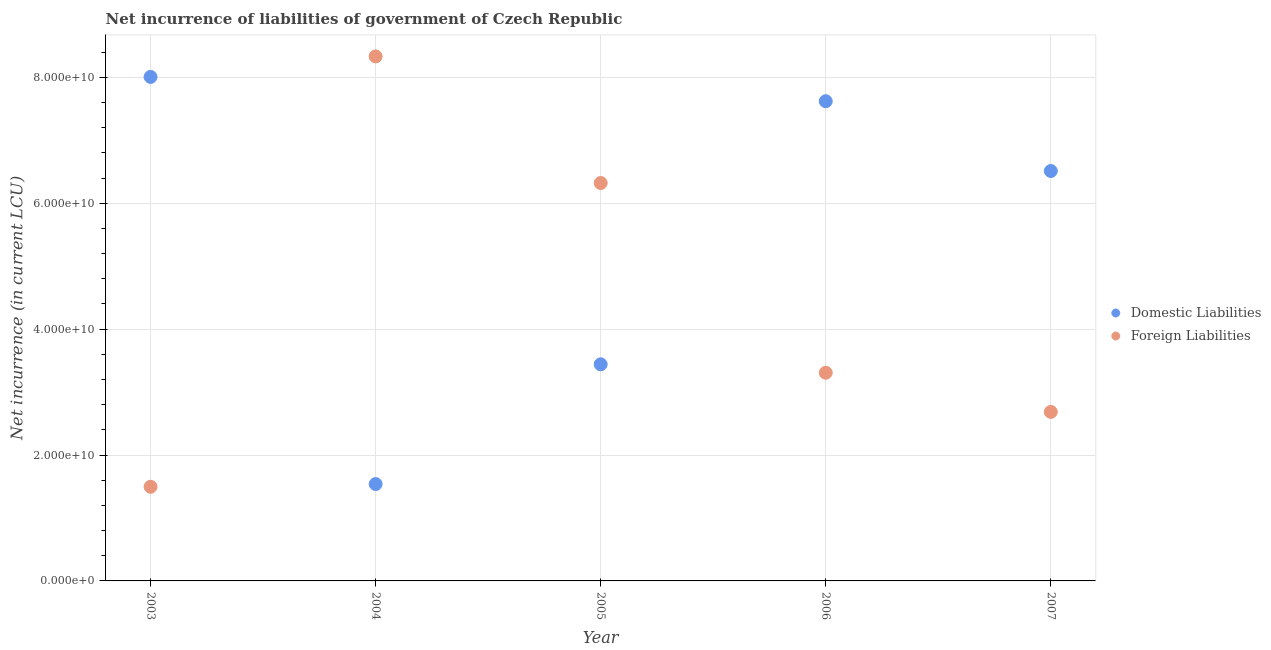How many different coloured dotlines are there?
Offer a very short reply. 2. What is the net incurrence of foreign liabilities in 2003?
Your answer should be compact. 1.50e+1. Across all years, what is the maximum net incurrence of domestic liabilities?
Your answer should be compact. 8.01e+1. Across all years, what is the minimum net incurrence of foreign liabilities?
Offer a terse response. 1.50e+1. In which year was the net incurrence of domestic liabilities maximum?
Give a very brief answer. 2003. What is the total net incurrence of domestic liabilities in the graph?
Ensure brevity in your answer.  2.71e+11. What is the difference between the net incurrence of domestic liabilities in 2003 and that in 2005?
Make the answer very short. 4.57e+1. What is the difference between the net incurrence of domestic liabilities in 2003 and the net incurrence of foreign liabilities in 2007?
Your answer should be compact. 5.32e+1. What is the average net incurrence of foreign liabilities per year?
Offer a terse response. 4.43e+1. In the year 2003, what is the difference between the net incurrence of domestic liabilities and net incurrence of foreign liabilities?
Offer a terse response. 6.51e+1. In how many years, is the net incurrence of foreign liabilities greater than 68000000000 LCU?
Offer a terse response. 1. What is the ratio of the net incurrence of foreign liabilities in 2003 to that in 2006?
Keep it short and to the point. 0.45. Is the net incurrence of foreign liabilities in 2004 less than that in 2007?
Provide a succinct answer. No. What is the difference between the highest and the second highest net incurrence of domestic liabilities?
Give a very brief answer. 3.86e+09. What is the difference between the highest and the lowest net incurrence of foreign liabilities?
Your answer should be compact. 6.84e+1. In how many years, is the net incurrence of foreign liabilities greater than the average net incurrence of foreign liabilities taken over all years?
Provide a succinct answer. 2. Does the net incurrence of foreign liabilities monotonically increase over the years?
Provide a short and direct response. No. Is the net incurrence of domestic liabilities strictly greater than the net incurrence of foreign liabilities over the years?
Make the answer very short. No. How many dotlines are there?
Make the answer very short. 2. How many years are there in the graph?
Your response must be concise. 5. Are the values on the major ticks of Y-axis written in scientific E-notation?
Ensure brevity in your answer.  Yes. How are the legend labels stacked?
Your answer should be very brief. Vertical. What is the title of the graph?
Ensure brevity in your answer.  Net incurrence of liabilities of government of Czech Republic. Does "Nonresident" appear as one of the legend labels in the graph?
Give a very brief answer. No. What is the label or title of the X-axis?
Your answer should be very brief. Year. What is the label or title of the Y-axis?
Provide a succinct answer. Net incurrence (in current LCU). What is the Net incurrence (in current LCU) of Domestic Liabilities in 2003?
Your response must be concise. 8.01e+1. What is the Net incurrence (in current LCU) of Foreign Liabilities in 2003?
Offer a terse response. 1.50e+1. What is the Net incurrence (in current LCU) of Domestic Liabilities in 2004?
Your answer should be very brief. 1.54e+1. What is the Net incurrence (in current LCU) in Foreign Liabilities in 2004?
Keep it short and to the point. 8.33e+1. What is the Net incurrence (in current LCU) in Domestic Liabilities in 2005?
Your answer should be compact. 3.44e+1. What is the Net incurrence (in current LCU) of Foreign Liabilities in 2005?
Your answer should be very brief. 6.32e+1. What is the Net incurrence (in current LCU) of Domestic Liabilities in 2006?
Give a very brief answer. 7.62e+1. What is the Net incurrence (in current LCU) in Foreign Liabilities in 2006?
Offer a terse response. 3.31e+1. What is the Net incurrence (in current LCU) of Domestic Liabilities in 2007?
Provide a succinct answer. 6.51e+1. What is the Net incurrence (in current LCU) of Foreign Liabilities in 2007?
Provide a short and direct response. 2.69e+1. Across all years, what is the maximum Net incurrence (in current LCU) of Domestic Liabilities?
Your answer should be very brief. 8.01e+1. Across all years, what is the maximum Net incurrence (in current LCU) of Foreign Liabilities?
Your response must be concise. 8.33e+1. Across all years, what is the minimum Net incurrence (in current LCU) in Domestic Liabilities?
Offer a terse response. 1.54e+1. Across all years, what is the minimum Net incurrence (in current LCU) of Foreign Liabilities?
Ensure brevity in your answer.  1.50e+1. What is the total Net incurrence (in current LCU) of Domestic Liabilities in the graph?
Offer a very short reply. 2.71e+11. What is the total Net incurrence (in current LCU) of Foreign Liabilities in the graph?
Provide a succinct answer. 2.21e+11. What is the difference between the Net incurrence (in current LCU) of Domestic Liabilities in 2003 and that in 2004?
Provide a short and direct response. 6.47e+1. What is the difference between the Net incurrence (in current LCU) in Foreign Liabilities in 2003 and that in 2004?
Your answer should be compact. -6.84e+1. What is the difference between the Net incurrence (in current LCU) in Domestic Liabilities in 2003 and that in 2005?
Give a very brief answer. 4.57e+1. What is the difference between the Net incurrence (in current LCU) of Foreign Liabilities in 2003 and that in 2005?
Your response must be concise. -4.83e+1. What is the difference between the Net incurrence (in current LCU) in Domestic Liabilities in 2003 and that in 2006?
Your answer should be compact. 3.86e+09. What is the difference between the Net incurrence (in current LCU) in Foreign Liabilities in 2003 and that in 2006?
Make the answer very short. -1.81e+1. What is the difference between the Net incurrence (in current LCU) of Domestic Liabilities in 2003 and that in 2007?
Your answer should be compact. 1.49e+1. What is the difference between the Net incurrence (in current LCU) of Foreign Liabilities in 2003 and that in 2007?
Keep it short and to the point. -1.19e+1. What is the difference between the Net incurrence (in current LCU) of Domestic Liabilities in 2004 and that in 2005?
Make the answer very short. -1.90e+1. What is the difference between the Net incurrence (in current LCU) in Foreign Liabilities in 2004 and that in 2005?
Make the answer very short. 2.01e+1. What is the difference between the Net incurrence (in current LCU) in Domestic Liabilities in 2004 and that in 2006?
Provide a short and direct response. -6.08e+1. What is the difference between the Net incurrence (in current LCU) of Foreign Liabilities in 2004 and that in 2006?
Offer a very short reply. 5.03e+1. What is the difference between the Net incurrence (in current LCU) of Domestic Liabilities in 2004 and that in 2007?
Make the answer very short. -4.97e+1. What is the difference between the Net incurrence (in current LCU) of Foreign Liabilities in 2004 and that in 2007?
Offer a terse response. 5.65e+1. What is the difference between the Net incurrence (in current LCU) of Domestic Liabilities in 2005 and that in 2006?
Give a very brief answer. -4.18e+1. What is the difference between the Net incurrence (in current LCU) in Foreign Liabilities in 2005 and that in 2006?
Give a very brief answer. 3.01e+1. What is the difference between the Net incurrence (in current LCU) in Domestic Liabilities in 2005 and that in 2007?
Ensure brevity in your answer.  -3.07e+1. What is the difference between the Net incurrence (in current LCU) of Foreign Liabilities in 2005 and that in 2007?
Your answer should be very brief. 3.64e+1. What is the difference between the Net incurrence (in current LCU) in Domestic Liabilities in 2006 and that in 2007?
Your answer should be compact. 1.11e+1. What is the difference between the Net incurrence (in current LCU) in Foreign Liabilities in 2006 and that in 2007?
Your response must be concise. 6.21e+09. What is the difference between the Net incurrence (in current LCU) in Domestic Liabilities in 2003 and the Net incurrence (in current LCU) in Foreign Liabilities in 2004?
Give a very brief answer. -3.26e+09. What is the difference between the Net incurrence (in current LCU) in Domestic Liabilities in 2003 and the Net incurrence (in current LCU) in Foreign Liabilities in 2005?
Offer a terse response. 1.69e+1. What is the difference between the Net incurrence (in current LCU) of Domestic Liabilities in 2003 and the Net incurrence (in current LCU) of Foreign Liabilities in 2006?
Give a very brief answer. 4.70e+1. What is the difference between the Net incurrence (in current LCU) in Domestic Liabilities in 2003 and the Net incurrence (in current LCU) in Foreign Liabilities in 2007?
Provide a short and direct response. 5.32e+1. What is the difference between the Net incurrence (in current LCU) of Domestic Liabilities in 2004 and the Net incurrence (in current LCU) of Foreign Liabilities in 2005?
Ensure brevity in your answer.  -4.78e+1. What is the difference between the Net incurrence (in current LCU) in Domestic Liabilities in 2004 and the Net incurrence (in current LCU) in Foreign Liabilities in 2006?
Ensure brevity in your answer.  -1.77e+1. What is the difference between the Net incurrence (in current LCU) in Domestic Liabilities in 2004 and the Net incurrence (in current LCU) in Foreign Liabilities in 2007?
Your response must be concise. -1.15e+1. What is the difference between the Net incurrence (in current LCU) of Domestic Liabilities in 2005 and the Net incurrence (in current LCU) of Foreign Liabilities in 2006?
Give a very brief answer. 1.34e+09. What is the difference between the Net incurrence (in current LCU) in Domestic Liabilities in 2005 and the Net incurrence (in current LCU) in Foreign Liabilities in 2007?
Make the answer very short. 7.56e+09. What is the difference between the Net incurrence (in current LCU) of Domestic Liabilities in 2006 and the Net incurrence (in current LCU) of Foreign Liabilities in 2007?
Provide a short and direct response. 4.93e+1. What is the average Net incurrence (in current LCU) in Domestic Liabilities per year?
Your response must be concise. 5.42e+1. What is the average Net incurrence (in current LCU) in Foreign Liabilities per year?
Your answer should be very brief. 4.43e+1. In the year 2003, what is the difference between the Net incurrence (in current LCU) of Domestic Liabilities and Net incurrence (in current LCU) of Foreign Liabilities?
Make the answer very short. 6.51e+1. In the year 2004, what is the difference between the Net incurrence (in current LCU) of Domestic Liabilities and Net incurrence (in current LCU) of Foreign Liabilities?
Offer a terse response. -6.79e+1. In the year 2005, what is the difference between the Net incurrence (in current LCU) of Domestic Liabilities and Net incurrence (in current LCU) of Foreign Liabilities?
Keep it short and to the point. -2.88e+1. In the year 2006, what is the difference between the Net incurrence (in current LCU) in Domestic Liabilities and Net incurrence (in current LCU) in Foreign Liabilities?
Provide a short and direct response. 4.31e+1. In the year 2007, what is the difference between the Net incurrence (in current LCU) in Domestic Liabilities and Net incurrence (in current LCU) in Foreign Liabilities?
Give a very brief answer. 3.83e+1. What is the ratio of the Net incurrence (in current LCU) of Domestic Liabilities in 2003 to that in 2004?
Provide a short and direct response. 5.2. What is the ratio of the Net incurrence (in current LCU) in Foreign Liabilities in 2003 to that in 2004?
Ensure brevity in your answer.  0.18. What is the ratio of the Net incurrence (in current LCU) of Domestic Liabilities in 2003 to that in 2005?
Your answer should be very brief. 2.33. What is the ratio of the Net incurrence (in current LCU) in Foreign Liabilities in 2003 to that in 2005?
Make the answer very short. 0.24. What is the ratio of the Net incurrence (in current LCU) in Domestic Liabilities in 2003 to that in 2006?
Provide a succinct answer. 1.05. What is the ratio of the Net incurrence (in current LCU) of Foreign Liabilities in 2003 to that in 2006?
Give a very brief answer. 0.45. What is the ratio of the Net incurrence (in current LCU) in Domestic Liabilities in 2003 to that in 2007?
Provide a succinct answer. 1.23. What is the ratio of the Net incurrence (in current LCU) in Foreign Liabilities in 2003 to that in 2007?
Ensure brevity in your answer.  0.56. What is the ratio of the Net incurrence (in current LCU) in Domestic Liabilities in 2004 to that in 2005?
Give a very brief answer. 0.45. What is the ratio of the Net incurrence (in current LCU) in Foreign Liabilities in 2004 to that in 2005?
Your answer should be very brief. 1.32. What is the ratio of the Net incurrence (in current LCU) of Domestic Liabilities in 2004 to that in 2006?
Your answer should be very brief. 0.2. What is the ratio of the Net incurrence (in current LCU) in Foreign Liabilities in 2004 to that in 2006?
Offer a terse response. 2.52. What is the ratio of the Net incurrence (in current LCU) of Domestic Liabilities in 2004 to that in 2007?
Offer a very short reply. 0.24. What is the ratio of the Net incurrence (in current LCU) in Foreign Liabilities in 2004 to that in 2007?
Provide a succinct answer. 3.1. What is the ratio of the Net incurrence (in current LCU) of Domestic Liabilities in 2005 to that in 2006?
Your response must be concise. 0.45. What is the ratio of the Net incurrence (in current LCU) in Foreign Liabilities in 2005 to that in 2006?
Offer a very short reply. 1.91. What is the ratio of the Net incurrence (in current LCU) of Domestic Liabilities in 2005 to that in 2007?
Offer a very short reply. 0.53. What is the ratio of the Net incurrence (in current LCU) of Foreign Liabilities in 2005 to that in 2007?
Keep it short and to the point. 2.35. What is the ratio of the Net incurrence (in current LCU) in Domestic Liabilities in 2006 to that in 2007?
Provide a succinct answer. 1.17. What is the ratio of the Net incurrence (in current LCU) of Foreign Liabilities in 2006 to that in 2007?
Offer a very short reply. 1.23. What is the difference between the highest and the second highest Net incurrence (in current LCU) of Domestic Liabilities?
Give a very brief answer. 3.86e+09. What is the difference between the highest and the second highest Net incurrence (in current LCU) of Foreign Liabilities?
Offer a very short reply. 2.01e+1. What is the difference between the highest and the lowest Net incurrence (in current LCU) of Domestic Liabilities?
Your answer should be compact. 6.47e+1. What is the difference between the highest and the lowest Net incurrence (in current LCU) in Foreign Liabilities?
Your response must be concise. 6.84e+1. 